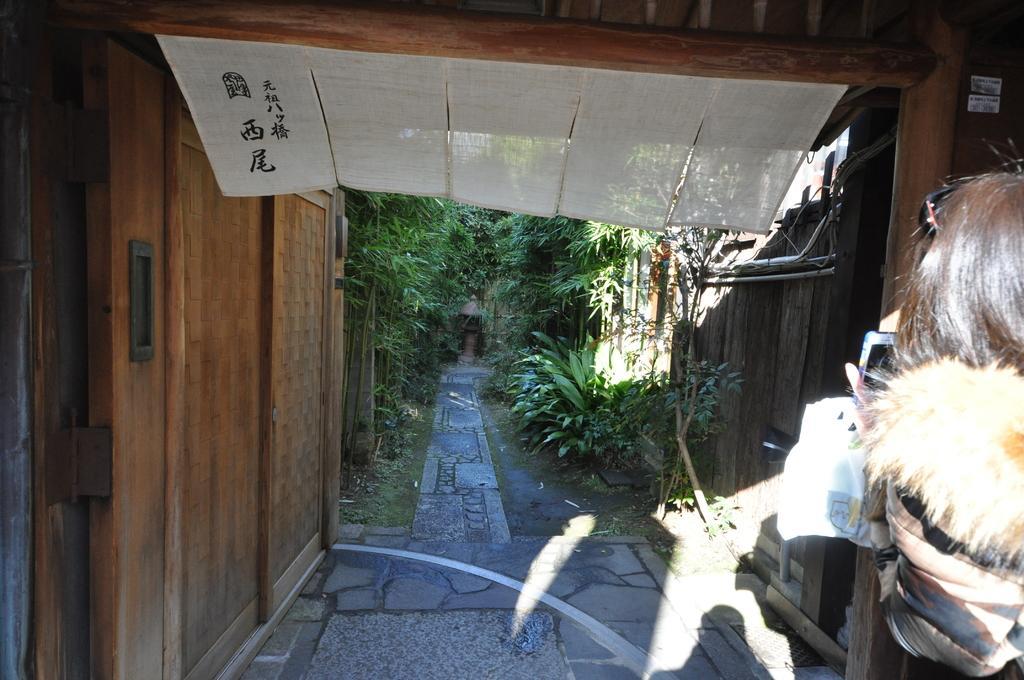Please provide a concise description of this image. In this image in the front on the right side there is a person. In the background there are trees and there's grass on the ground, on the left side there is a door. On the right side there is a wooden fence. On the top there are objects which are white in colour 